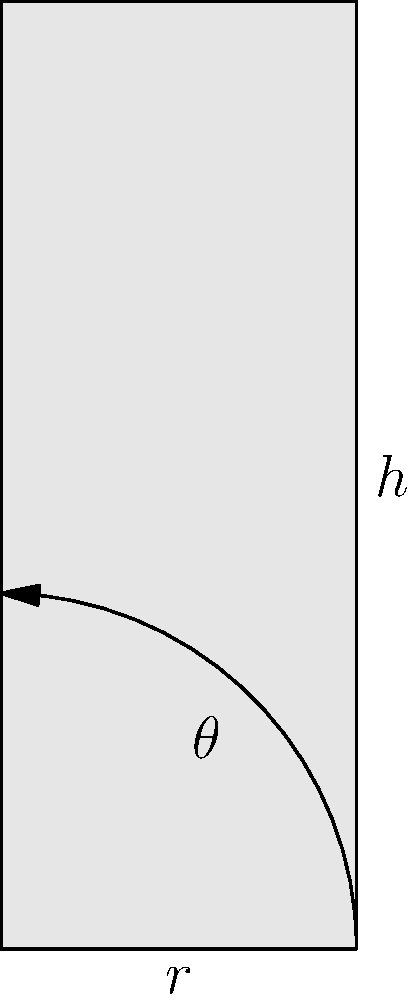As a NASA astronaut collaborating on a lunar base design, you need to calculate the cross-sectional area of a cylindrical module. The module has a radius of 3 meters and a height of 8 meters. What is the cross-sectional area of this module? To calculate the cross-sectional area of a cylindrical module, we need to use the formula for the area of a circle, since the cross-section of a cylinder is a circle.

The formula for the area of a circle is:

$$A = \pi r^2$$

Where:
$A$ is the area
$\pi$ is pi (approximately 3.14159)
$r$ is the radius

Given:
Radius ($r$) = 3 meters

Step 1: Substitute the radius into the formula
$$A = \pi (3)^2$$

Step 2: Calculate the square of the radius
$$A = \pi (9)$$

Step 3: Multiply by pi
$$A = 28.27 \text{ m}^2$$ (rounded to two decimal places)

Therefore, the cross-sectional area of the cylindrical module is approximately 28.27 square meters.
Answer: $28.27 \text{ m}^2$ 